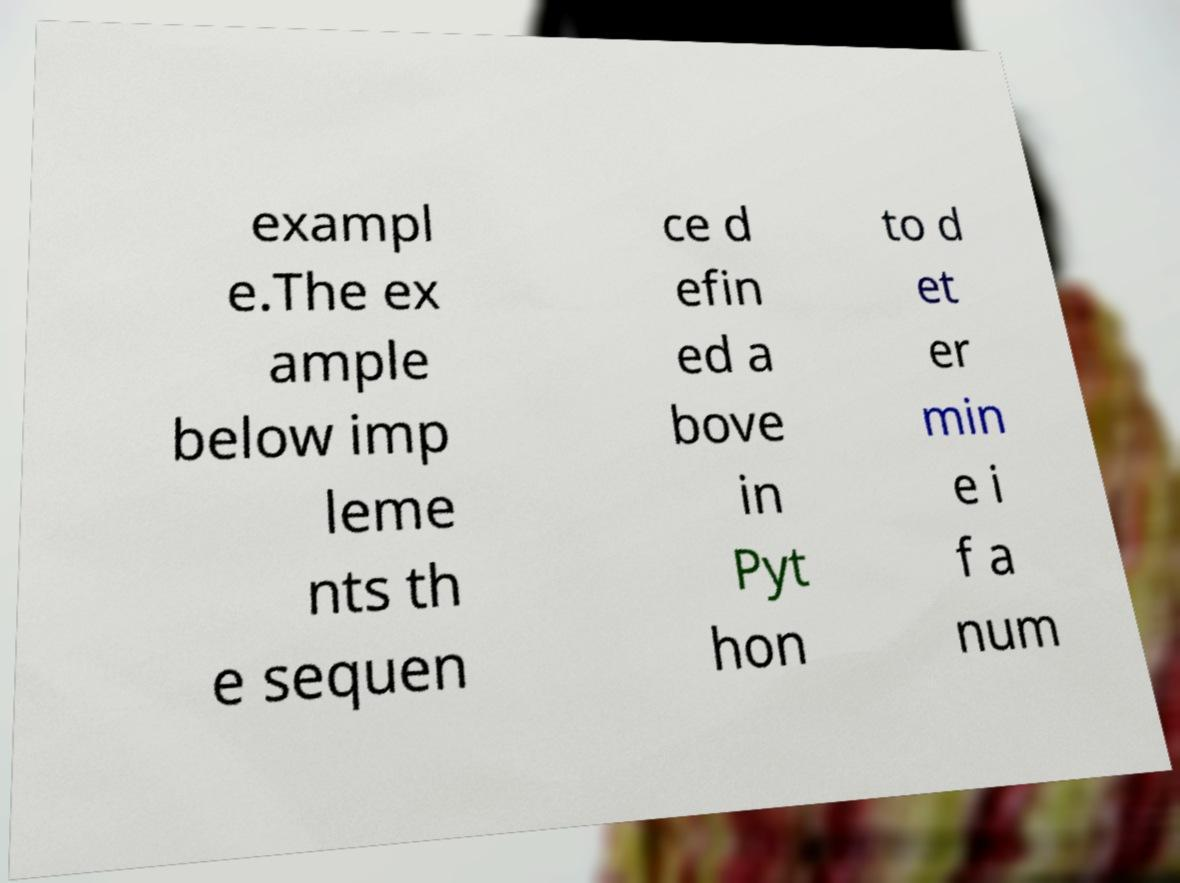Please identify and transcribe the text found in this image. exampl e.The ex ample below imp leme nts th e sequen ce d efin ed a bove in Pyt hon to d et er min e i f a num 